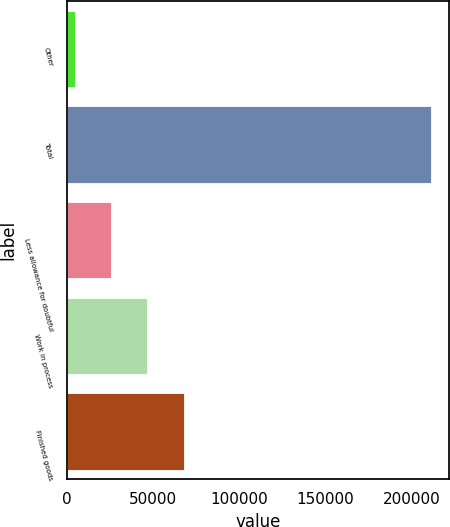Convert chart to OTSL. <chart><loc_0><loc_0><loc_500><loc_500><bar_chart><fcel>Other<fcel>Total<fcel>Less allowance for doubtful<fcel>Work in process<fcel>Finished goods<nl><fcel>5093<fcel>210869<fcel>25670.6<fcel>46248.2<fcel>67805<nl></chart> 